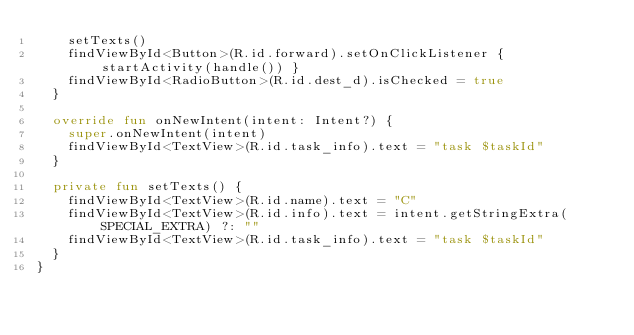<code> <loc_0><loc_0><loc_500><loc_500><_Kotlin_>    setTexts()
    findViewById<Button>(R.id.forward).setOnClickListener { startActivity(handle()) }
    findViewById<RadioButton>(R.id.dest_d).isChecked = true
  }

  override fun onNewIntent(intent: Intent?) {
    super.onNewIntent(intent)
    findViewById<TextView>(R.id.task_info).text = "task $taskId"
  }

  private fun setTexts() {
    findViewById<TextView>(R.id.name).text = "C"
    findViewById<TextView>(R.id.info).text = intent.getStringExtra(SPECIAL_EXTRA) ?: ""
    findViewById<TextView>(R.id.task_info).text = "task $taskId"
  }
}
</code> 